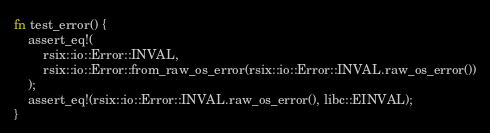Convert code to text. <code><loc_0><loc_0><loc_500><loc_500><_Rust_>fn test_error() {
    assert_eq!(
        rsix::io::Error::INVAL,
        rsix::io::Error::from_raw_os_error(rsix::io::Error::INVAL.raw_os_error())
    );
    assert_eq!(rsix::io::Error::INVAL.raw_os_error(), libc::EINVAL);
}
</code> 